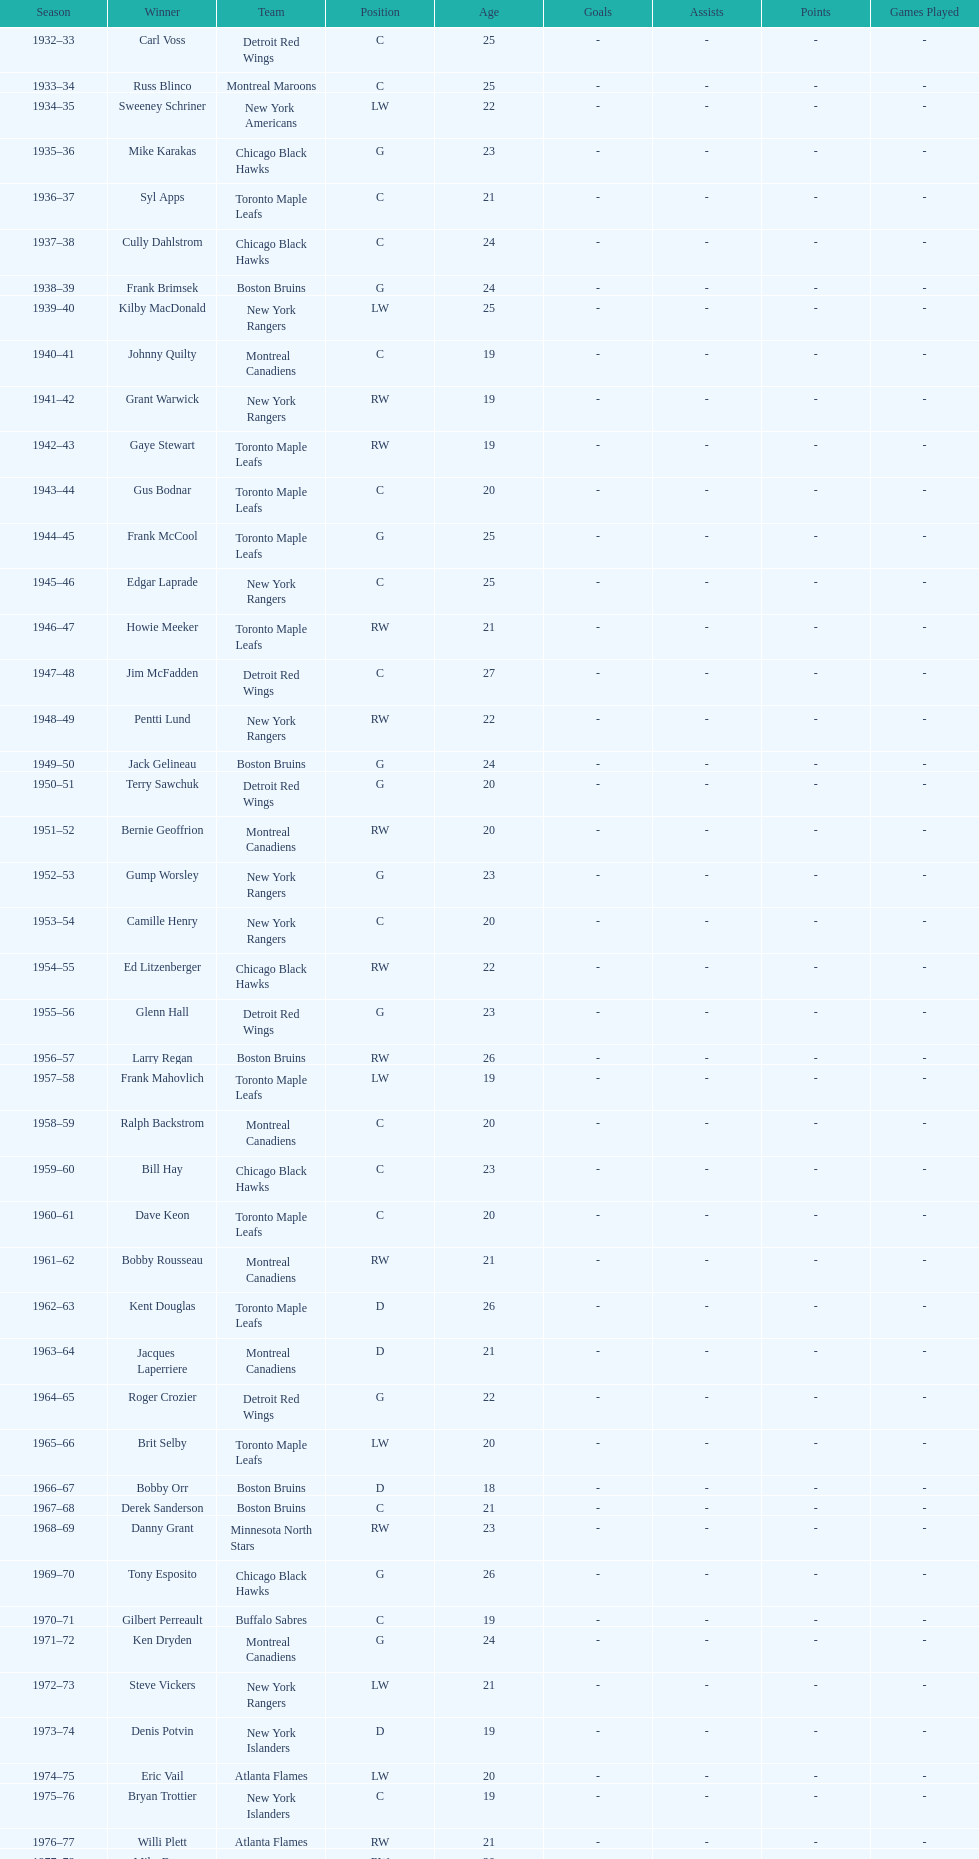Can you parse all the data within this table? {'header': ['Season', 'Winner', 'Team', 'Position', 'Age', 'Goals', 'Assists', 'Points', 'Games Played'], 'rows': [['1932–33', 'Carl Voss', 'Detroit Red Wings', 'C', '25', '-', '-', '-', '-'], ['1933–34', 'Russ Blinco', 'Montreal Maroons', 'C', '25', '-', '-', '-', '-'], ['1934–35', 'Sweeney Schriner', 'New York Americans', 'LW', '22', '-', '-', '-', '-'], ['1935–36', 'Mike Karakas', 'Chicago Black Hawks', 'G', '23', '-', '-', '-', '-'], ['1936–37', 'Syl Apps', 'Toronto Maple Leafs', 'C', '21', '-', '-', '-', '-'], ['1937–38', 'Cully Dahlstrom', 'Chicago Black Hawks', 'C', '24', '-', '-', '-', '-'], ['1938–39', 'Frank Brimsek', 'Boston Bruins', 'G', '24', '-', '-', '-', '-'], ['1939–40', 'Kilby MacDonald', 'New York Rangers', 'LW', '25', '-', '-', '-', '-'], ['1940–41', 'Johnny Quilty', 'Montreal Canadiens', 'C', '19', '-', '-', '-', '-'], ['1941–42', 'Grant Warwick', 'New York Rangers', 'RW', '19', '-', '-', '-', '-'], ['1942–43', 'Gaye Stewart', 'Toronto Maple Leafs', 'RW', '19', '-', '-', '-', '-'], ['1943–44', 'Gus Bodnar', 'Toronto Maple Leafs', 'C', '20', '-', '-', '-', '-'], ['1944–45', 'Frank McCool', 'Toronto Maple Leafs', 'G', '25', '-', '-', '-', '-'], ['1945–46', 'Edgar Laprade', 'New York Rangers', 'C', '25', '-', '-', '-', '-'], ['1946–47', 'Howie Meeker', 'Toronto Maple Leafs', 'RW', '21', '-', '-', '-', '-'], ['1947–48', 'Jim McFadden', 'Detroit Red Wings', 'C', '27', '-', '-', '-', '-'], ['1948–49', 'Pentti Lund', 'New York Rangers', 'RW', '22', '-', '-', '-', '-'], ['1949–50', 'Jack Gelineau', 'Boston Bruins', 'G', '24', '-', '-', '-', '-'], ['1950–51', 'Terry Sawchuk', 'Detroit Red Wings', 'G', '20', '-', '-', '-', '-'], ['1951–52', 'Bernie Geoffrion', 'Montreal Canadiens', 'RW', '20', '-', '-', '-', '-'], ['1952–53', 'Gump Worsley', 'New York Rangers', 'G', '23', '-', '-', '-', '-'], ['1953–54', 'Camille Henry', 'New York Rangers', 'C', '20', '-', '-', '-', '-'], ['1954–55', 'Ed Litzenberger', 'Chicago Black Hawks', 'RW', '22', '-', '-', '-', '-'], ['1955–56', 'Glenn Hall', 'Detroit Red Wings', 'G', '23', '-', '-', '-', '-'], ['1956–57', 'Larry Regan', 'Boston Bruins', 'RW', '26', '-', '-', '-', '-'], ['1957–58', 'Frank Mahovlich', 'Toronto Maple Leafs', 'LW', '19', '-', '-', '-', '-'], ['1958–59', 'Ralph Backstrom', 'Montreal Canadiens', 'C', '20', '-', '-', '-', '-'], ['1959–60', 'Bill Hay', 'Chicago Black Hawks', 'C', '23', '-', '-', '-', '-'], ['1960–61', 'Dave Keon', 'Toronto Maple Leafs', 'C', '20', '-', '-', '-', '-'], ['1961–62', 'Bobby Rousseau', 'Montreal Canadiens', 'RW', '21', '-', '-', '-', '-'], ['1962–63', 'Kent Douglas', 'Toronto Maple Leafs', 'D', '26', '-', '-', '-', '-'], ['1963–64', 'Jacques Laperriere', 'Montreal Canadiens', 'D', '21', '-', '-', '-', '-'], ['1964–65', 'Roger Crozier', 'Detroit Red Wings', 'G', '22', '-', '-', '-', '-'], ['1965–66', 'Brit Selby', 'Toronto Maple Leafs', 'LW', '20', '-', '-', '-', '-'], ['1966–67', 'Bobby Orr', 'Boston Bruins', 'D', '18', '-', '-', '-', '-'], ['1967–68', 'Derek Sanderson', 'Boston Bruins', 'C', '21', '-', '-', '-', '-'], ['1968–69', 'Danny Grant', 'Minnesota North Stars', 'RW', '23', '-', '-', '-', '-'], ['1969–70', 'Tony Esposito', 'Chicago Black Hawks', 'G', '26', '-', '-', '-', '-'], ['1970–71', 'Gilbert Perreault', 'Buffalo Sabres', 'C', '19', '-', '-', '-', '-'], ['1971–72', 'Ken Dryden', 'Montreal Canadiens', 'G', '24', '-', '-', '-', '-'], ['1972–73', 'Steve Vickers', 'New York Rangers', 'LW', '21', '-', '-', '-', '-'], ['1973–74', 'Denis Potvin', 'New York Islanders', 'D', '19', '-', '-', '-', '-'], ['1974–75', 'Eric Vail', 'Atlanta Flames', 'LW', '20', '-', '-', '-', '-'], ['1975–76', 'Bryan Trottier', 'New York Islanders', 'C', '19', '-', '-', '-', '-'], ['1976–77', 'Willi Plett', 'Atlanta Flames', 'RW', '21', '-', '-', '-', '-'], ['1977–78', 'Mike Bossy', 'New York Islanders', 'RW', '20', '-', '-', '-', '-'], ['1978–79', 'Bobby Smith', 'Minnesota North Stars', 'C', '20', '-', '-', '-', '-'], ['1979–80', 'Ray Bourque', 'Boston Bruins', 'D', '19', '-', '-', '-', '-'], ['1980–81', 'Peter Stastny', 'Quebec Nordiques', 'C', '24', '-', '-', '-', '-'], ['1981–82', 'Dale Hawerchuk', 'Winnipeg Jets', 'C', '18', '-', '-', '-', '-'], ['1982–83', 'Steve Larmer', 'Chicago Black Hawks', 'RW', '21', '-', '-', '-', '-'], ['1983–84', 'Tom Barrasso', 'Buffalo Sabres', 'G', '18', '-', '-', '-', '-'], ['1984–85', 'Mario Lemieux', 'Pittsburgh Penguins', 'C', '19', '-', '-', '-', '-'], ['1985–86', 'Gary Suter', 'Calgary Flames', 'D', '21', '-', '-', '-', '-'], ['1986–87', 'Luc Robitaille', 'Los Angeles Kings', 'LW', '20', '-', '-', '-', '-'], ['1987–88', 'Joe Nieuwendyk', 'Calgary Flames', 'C', '21', '-', '-', '-', '-'], ['1988–89', 'Brian Leetch', 'New York Rangers', 'D', '20', '-', '-', '-', '-'], ['1989–90', 'Sergei Makarov', 'Calgary Flames', 'RW', '31', '-', '-', '-', '-'], ['1990–91', 'Ed Belfour', 'Chicago Blackhawks', 'G', '25', '-', '-', '-', '-'], ['1991–92', 'Pavel Bure', 'Vancouver Canucks', 'RW', '20', '-', '-', '-', '-'], ['1992–93', 'Teemu Selanne', 'Winnipeg Jets', 'RW', '22', '-', '-', '-', '-'], ['1993–94', 'Martin Brodeur', 'New Jersey Devils', 'G', '21', '-', '-', '-', '-'], ['1994–95', 'Peter Forsberg', 'Quebec Nordiques', 'C', '21', '-', '-', '-', '-'], ['1995–96', 'Daniel Alfredsson', 'Ottawa Senators', 'RW', '22', '-', '-', '-', '-'], ['1996–97', 'Bryan Berard', 'New York Islanders', 'D', '19', '-', '-', '-', '-'], ['1997–98', 'Sergei Samsonov', 'Boston Bruins', 'LW', '19', '-', '-', '-', '-'], ['1998–99', 'Chris Drury', 'Colorado Avalanche', 'C', '22', '-', '-', '-', '-'], ['1999–2000', 'Scott Gomez', 'New Jersey Devils', 'C', '19', '-', '-', '-', '-'], ['2000–01', 'Evgeni Nabokov', 'San Jose Sharks', 'G', '25', '-', '-', '-', '-'], ['2001–02', 'Dany Heatley', 'Atlanta Thrashers', 'RW', '20', '-', '-', '-', '-'], ['2002–03', 'Barret Jackman', 'St. Louis Blues', 'D', '21', '-', '-', '-', '-'], ['2003–04', 'Andrew Raycroft', 'Boston Bruins', 'G', '23', '-', '-', '-', '-'], ['2004–05', 'No winner because of the\\n2004–05 NHL lockout', '-', '-', '-', '-', '-', '-', '-'], ['2005–06', 'Alexander Ovechkin', 'Washington Capitals', 'LW', '20', '-', '-', '-', '-'], ['2006–07', 'Evgeni Malkin', 'Pittsburgh Penguins', 'C', '20', '-', '-', '-', '-'], ['2007–08', 'Patrick Kane', 'Chicago Blackhawks', 'RW', '19', '-', '-', '-', '-'], ['2008–09', 'Steve Mason', 'Columbus Blue Jackets', 'G', '21', '-', '-', '-', '-'], ['2009–10', 'Tyler Myers', 'Buffalo Sabres', 'D', '20', '-', '-', '-', '-'], ['2010–11', 'Jeff Skinner', 'Carolina Hurricanes', 'C', '18', '-', '-', '-', '-'], ['2011–12', 'Gabriel Landeskog', 'Colorado Avalanche', 'LW', '19', '-', '-', '-', '-'], ['2012–13', 'Jonathan Huberdeau', 'Florida Panthers', 'C', '19', '-', '-', '-', '-']]} Which team has the highest number of consecutive calder memorial trophy winners? Toronto Maple Leafs. 